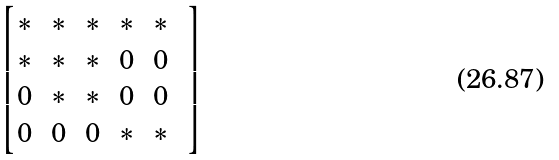<formula> <loc_0><loc_0><loc_500><loc_500>\begin{bmatrix} * & * & * & * & * \\ * & * & * & 0 & 0 \\ 0 & * & * & 0 & 0 & \\ 0 & 0 & 0 & * & * \end{bmatrix}</formula> 